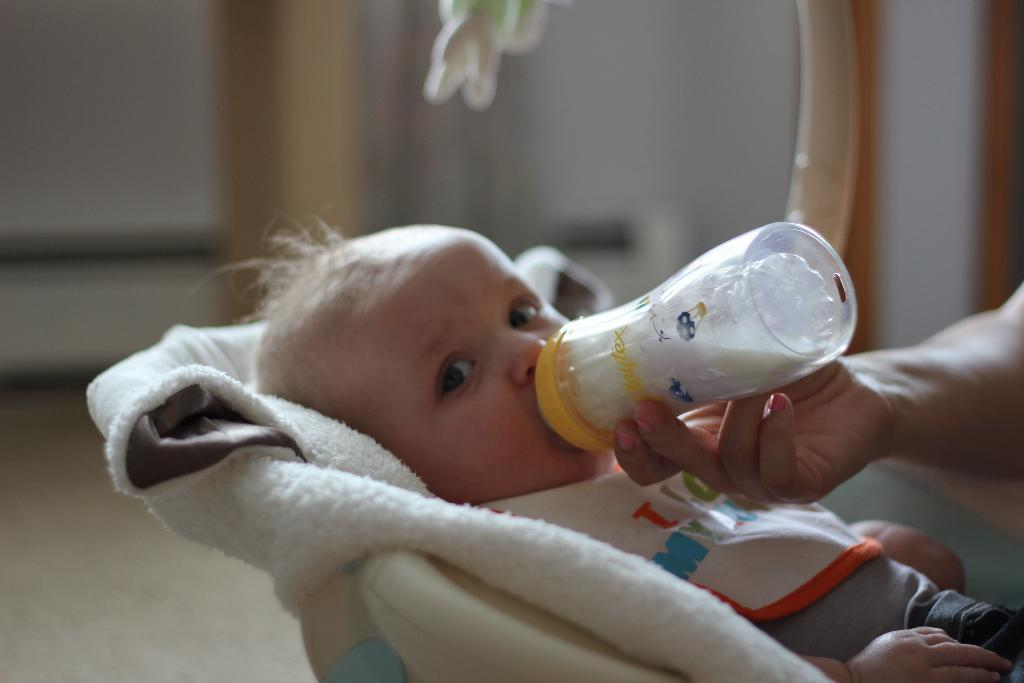What is the main subject of the image? There is a baby in the image. What is the baby doing in the image? The baby is drinking milk from a bottle. Whose hand is visible in the image? A person's hand is visible in the image. What is the background of the image like? There is a cloth behind the baby. What type of quince is being used as a toy for the baby in the image? There is no quince present in the image, and therefore no such toy can be observed. 